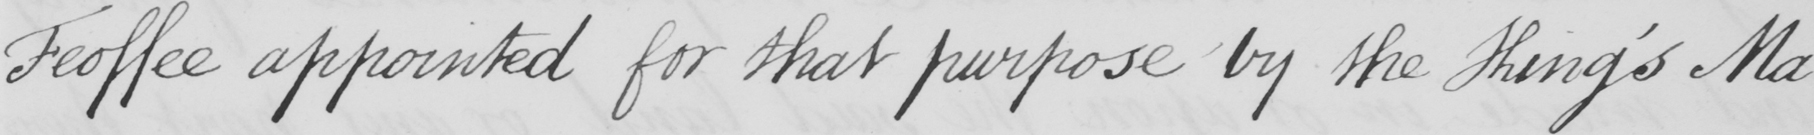Please transcribe the handwritten text in this image. Feoffee appointed for that purpose by the King ' s Ma- 